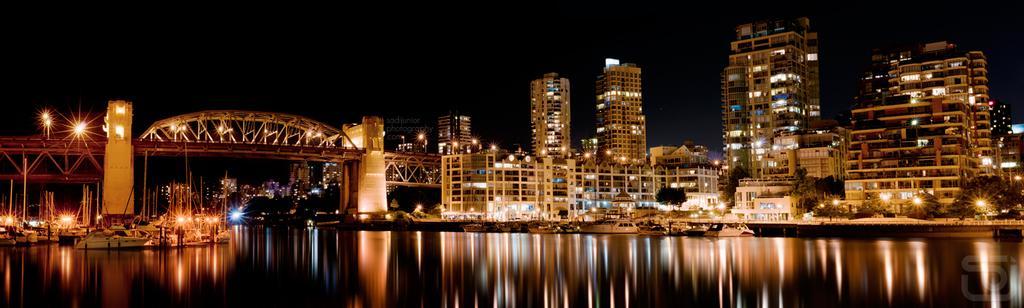Can you describe this image briefly? This image is taken in the dark where we can see water, ships floating on the water, bridge, buildings with lights, trees and the dark sky in the background. 